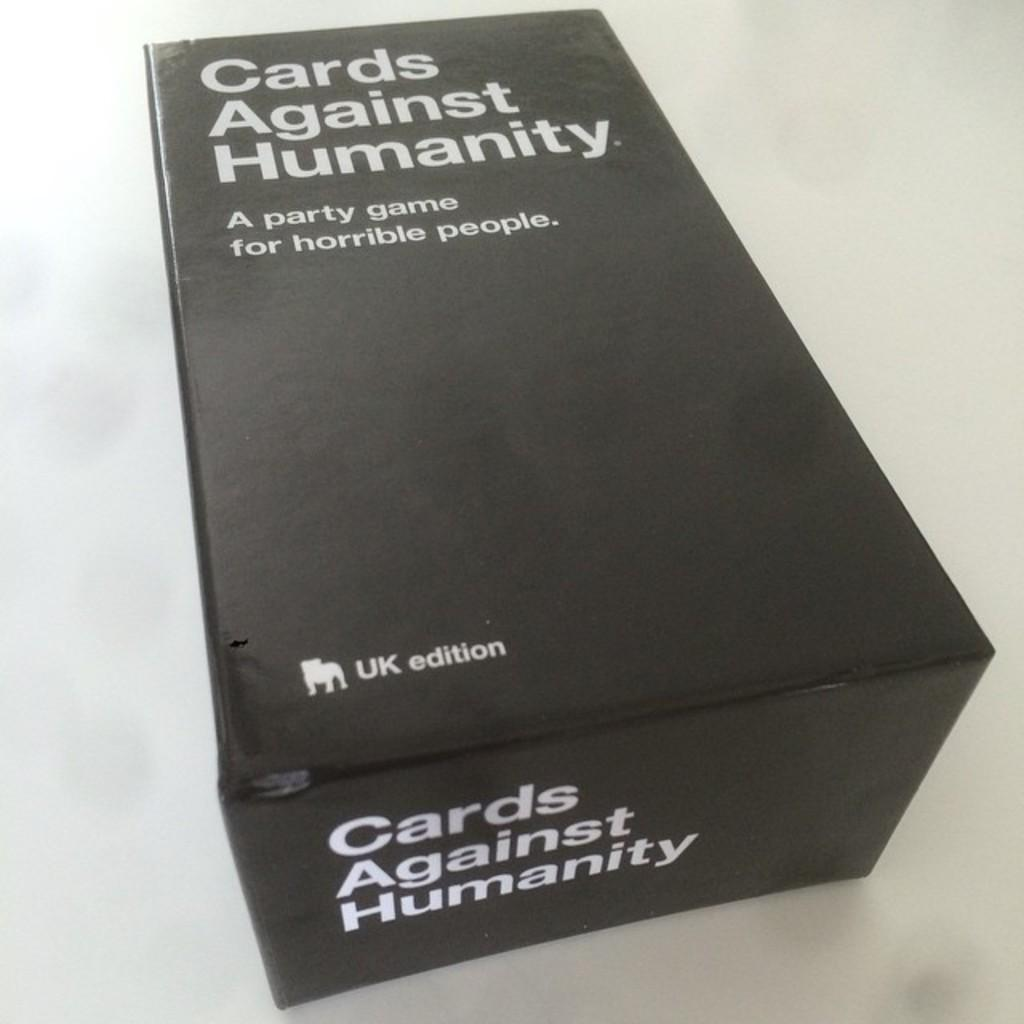<image>
Render a clear and concise summary of the photo. a black box with the words 'cards against humanity' on them 